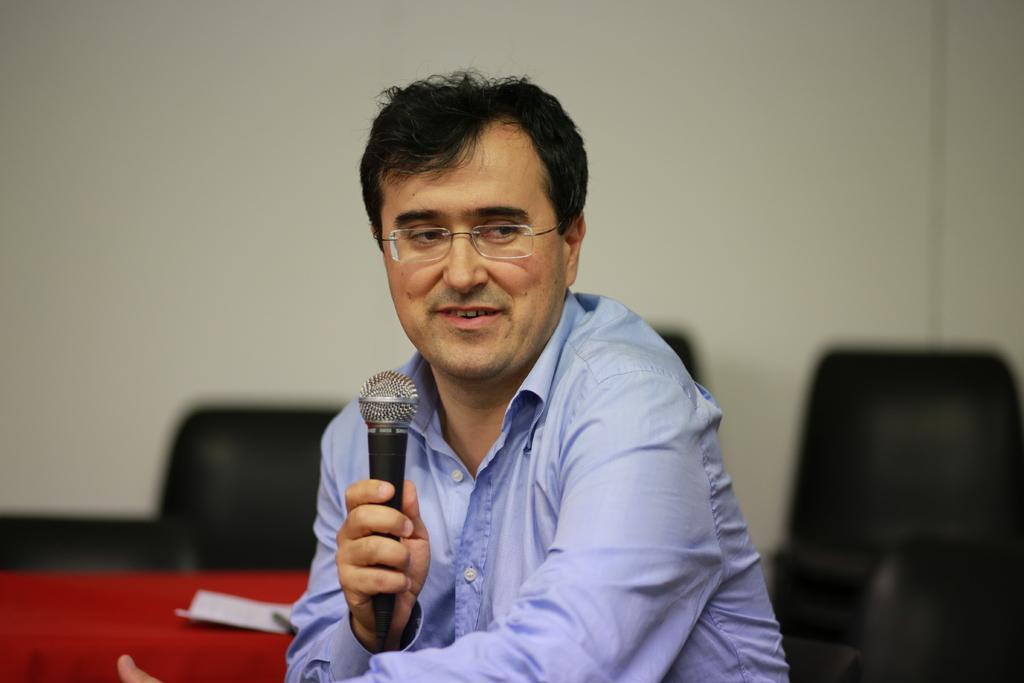Could you give a brief overview of what you see in this image? In this image there is a man wearing a spectacles , and holding a microphone , sitting in the chair, near the table and the back ground there is a wall. 